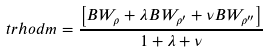Convert formula to latex. <formula><loc_0><loc_0><loc_500><loc_500>\ t r h o d m = \frac { \left [ B W _ { \rho } + \lambda B W _ { \rho ^ { \prime } } + \nu B W _ { \rho ^ { \prime \prime } } \right ] } { 1 + \lambda + \nu }</formula> 